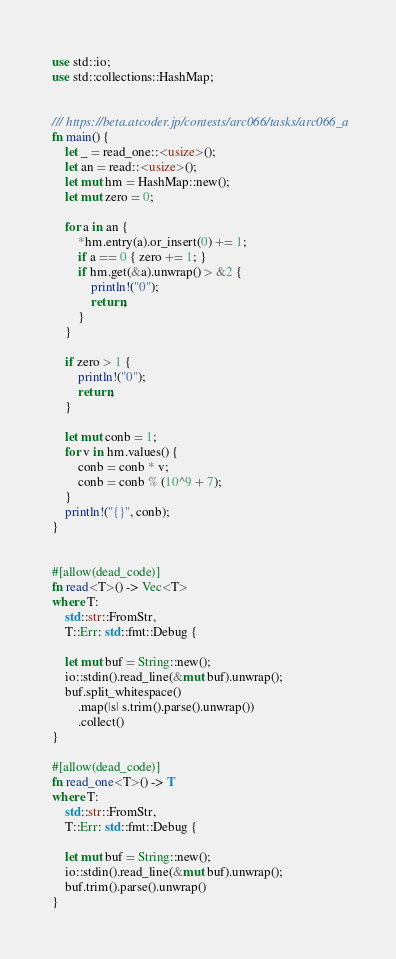<code> <loc_0><loc_0><loc_500><loc_500><_Rust_>use std::io;
use std::collections::HashMap;


/// https://beta.atcoder.jp/contests/arc066/tasks/arc066_a
fn main() {
    let _ = read_one::<usize>();
    let an = read::<usize>();
    let mut hm = HashMap::new();
    let mut zero = 0;

    for a in an {
        *hm.entry(a).or_insert(0) += 1;
        if a == 0 { zero += 1; }
        if hm.get(&a).unwrap() > &2 {
            println!("0");
            return;
        }
    }

    if zero > 1 {
        println!("0");
        return;
    }

    let mut conb = 1;
    for v in hm.values() {
        conb = conb * v;
        conb = conb % (10^9 + 7);
    }
    println!("{}", conb);
}


#[allow(dead_code)]
fn read<T>() -> Vec<T>
where T:
    std::str::FromStr,
    T::Err: std::fmt::Debug {

    let mut buf = String::new();
    io::stdin().read_line(&mut buf).unwrap();
    buf.split_whitespace()
        .map(|s| s.trim().parse().unwrap())
        .collect()
}

#[allow(dead_code)]
fn read_one<T>() -> T
where T:
    std::str::FromStr,
    T::Err: std::fmt::Debug {

    let mut buf = String::new();
    io::stdin().read_line(&mut buf).unwrap();
    buf.trim().parse().unwrap()
}</code> 